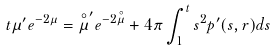Convert formula to latex. <formula><loc_0><loc_0><loc_500><loc_500>t \mu ^ { \prime } e ^ { - 2 \mu } = \overset { \circ } { \mu } ^ { \prime } e ^ { - 2 \overset { \circ } { \mu } } + 4 \pi \int _ { 1 } ^ { t } s ^ { 2 } p ^ { \prime } ( s , r ) d s</formula> 